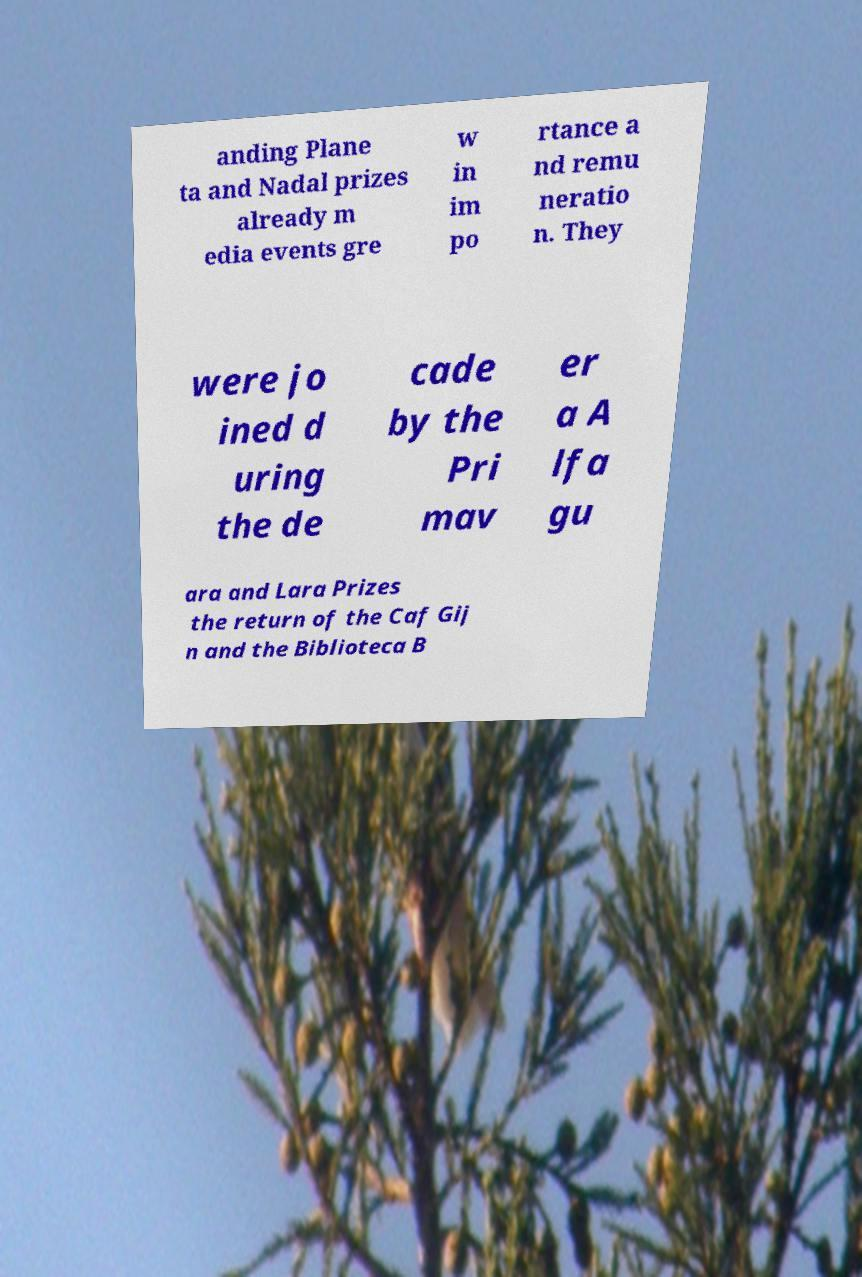There's text embedded in this image that I need extracted. Can you transcribe it verbatim? anding Plane ta and Nadal prizes already m edia events gre w in im po rtance a nd remu neratio n. They were jo ined d uring the de cade by the Pri mav er a A lfa gu ara and Lara Prizes the return of the Caf Gij n and the Biblioteca B 